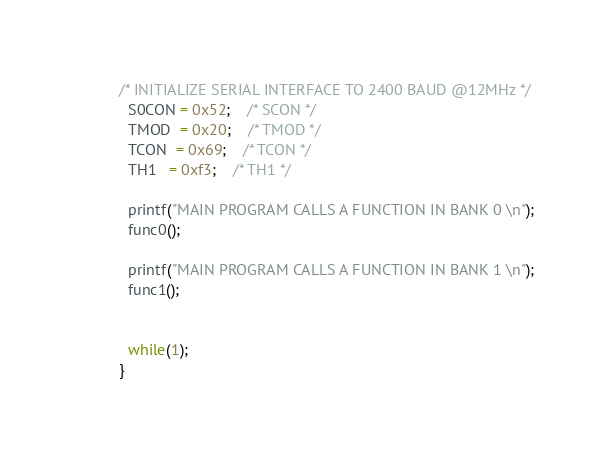<code> <loc_0><loc_0><loc_500><loc_500><_C_>
/* INITIALIZE SERIAL INTERFACE TO 2400 BAUD @12MHz */
  S0CON = 0x52;    /* SCON */
  TMOD  = 0x20;    /* TMOD */
  TCON  = 0x69;    /* TCON */
  TH1   = 0xf3;    /* TH1 */

  printf("MAIN PROGRAM CALLS A FUNCTION IN BANK 0 \n");
  func0();
 
  printf("MAIN PROGRAM CALLS A FUNCTION IN BANK 1 \n");
  func1();
 

  while(1);
}
</code> 